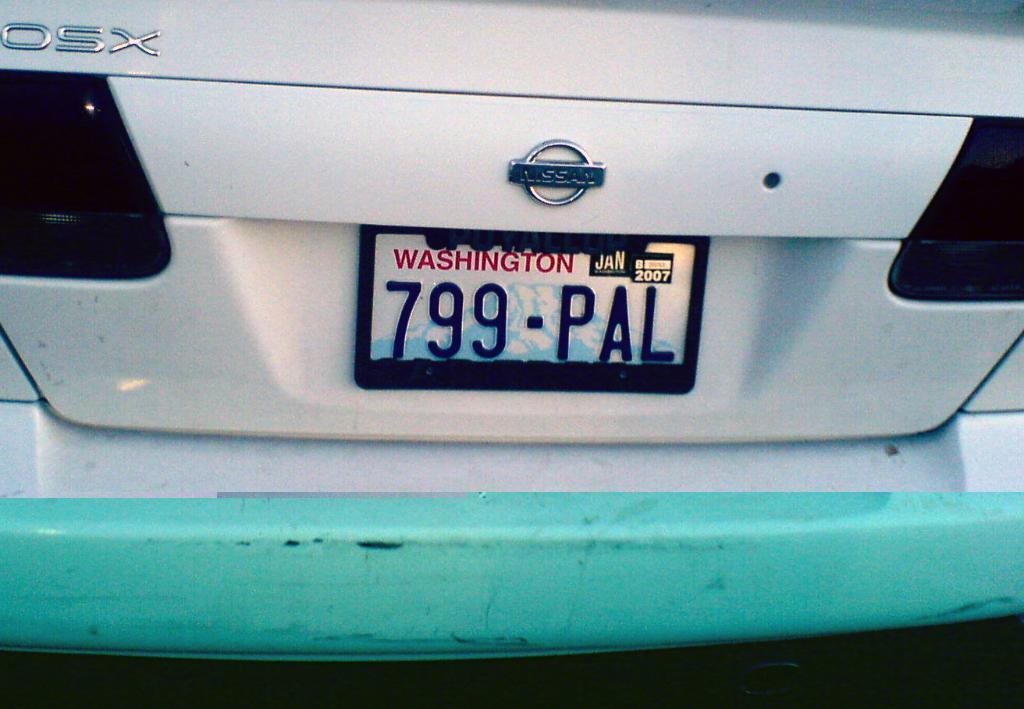What year is on the plate?
Ensure brevity in your answer.  2007. 